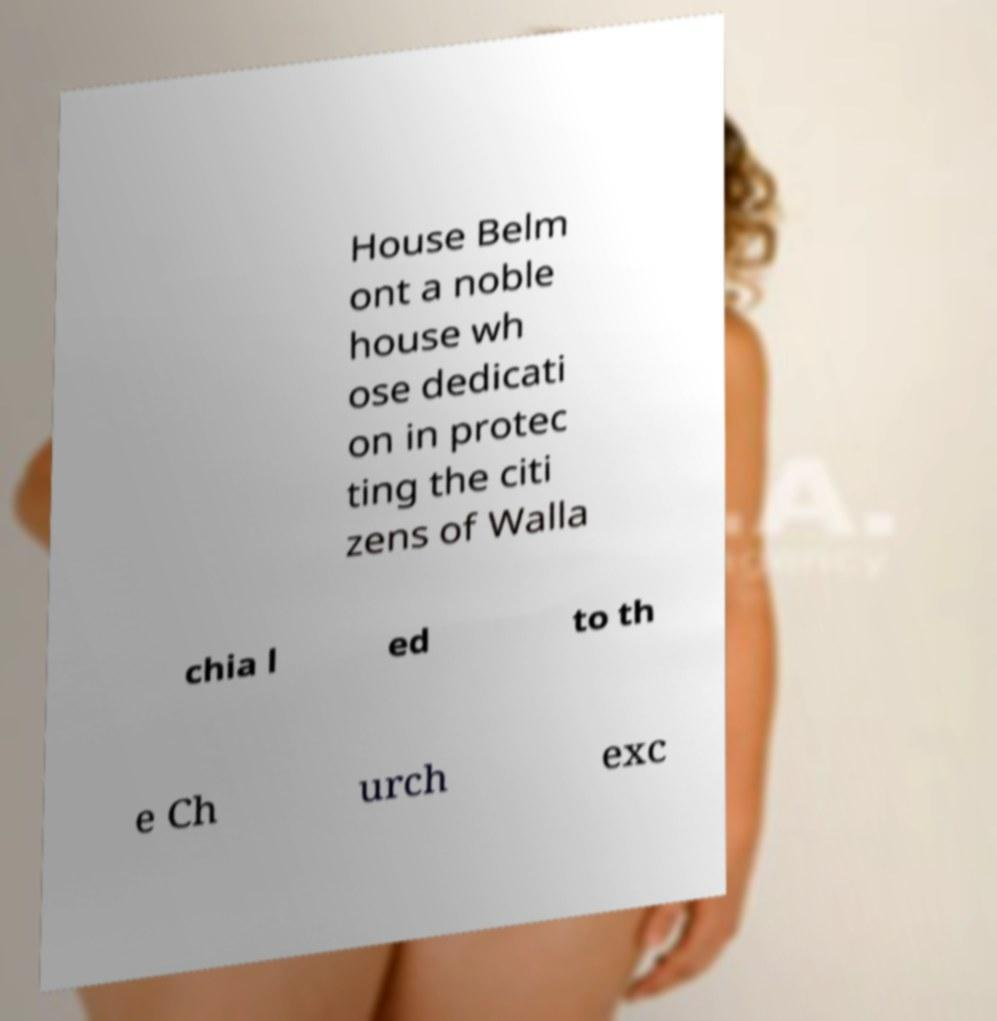Could you assist in decoding the text presented in this image and type it out clearly? House Belm ont a noble house wh ose dedicati on in protec ting the citi zens of Walla chia l ed to th e Ch urch exc 